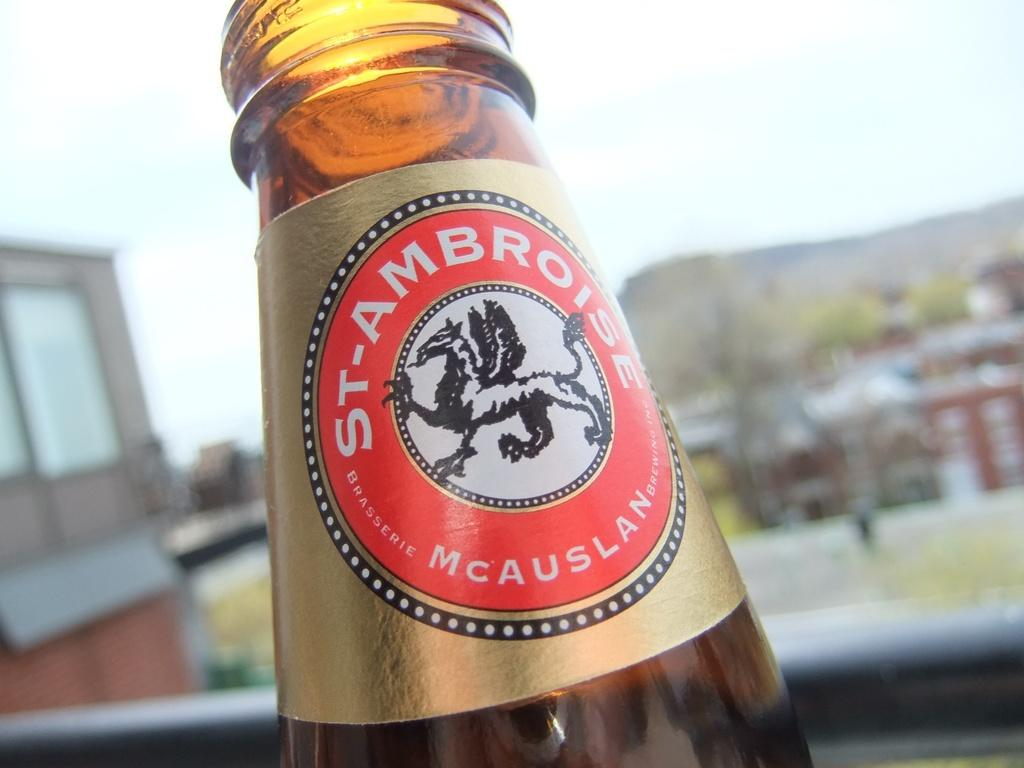What object can be seen in the image? There is a bottle in the image. What is unique about the bottle? The bottle has an animal photo on it. What type of brick is used to build the wall behind the bottle in the image? There is no wall or brick visible in the image; it only features a bottle with an animal photo on it. 